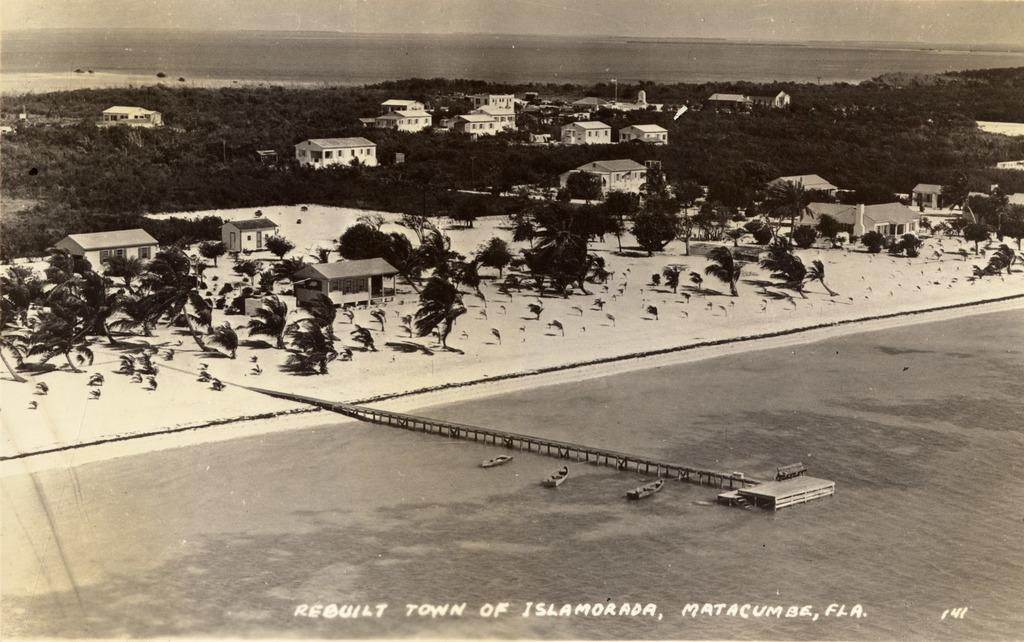<image>
Write a terse but informative summary of the picture. The black and white photo depicts the rebuilt town of Islamorada, Matacumbe, FLA. 